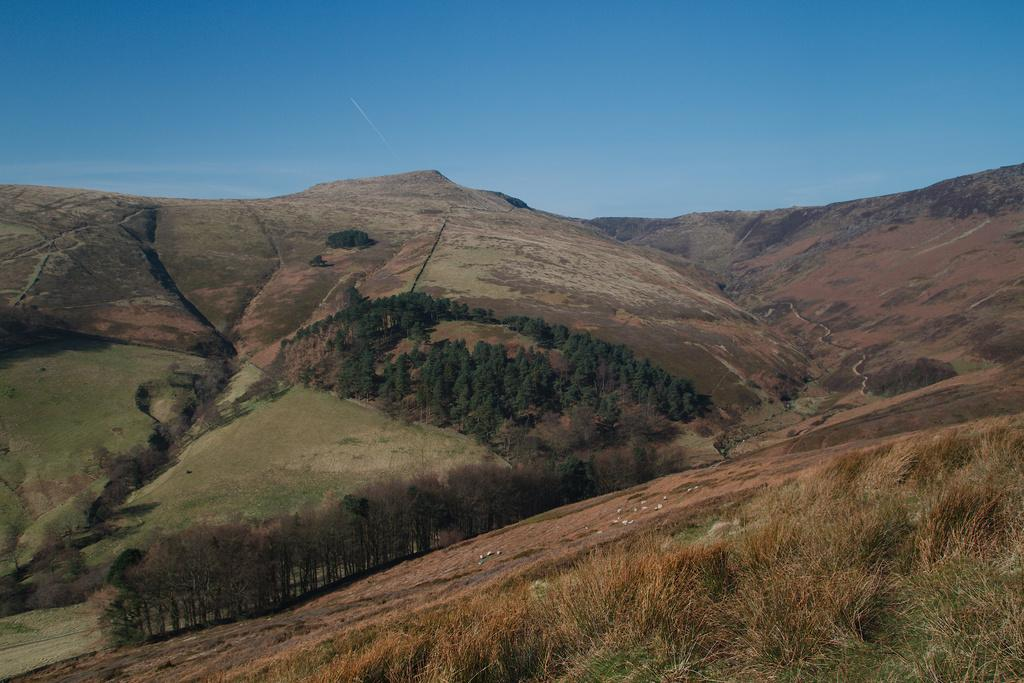What can be seen at the top of the image? The sky is visible in the image. What type of natural landforms are present in the image? There are mountains in the image. What type of vegetation is present on the mountains? Trees are present on the mountains. What type of ground cover can be seen in the image? There is grass visible in the image. What type of pleasure can be seen enjoying the grass in the image? There is no indication of any pleasure or creature enjoying the grass in the image. 